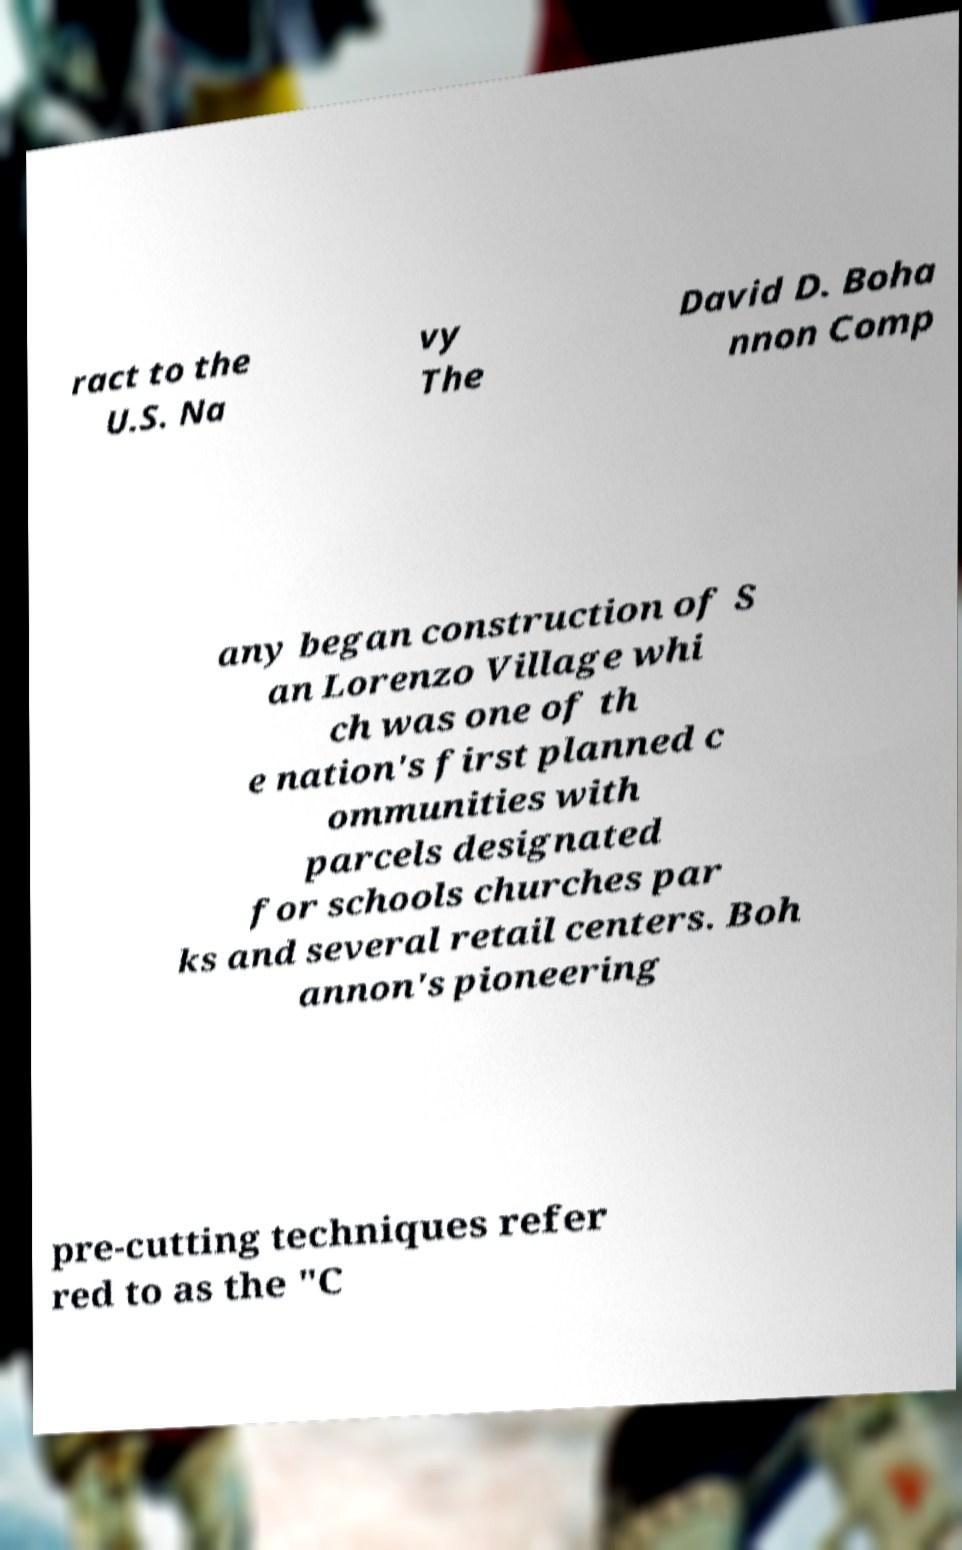Please identify and transcribe the text found in this image. ract to the U.S. Na vy The David D. Boha nnon Comp any began construction of S an Lorenzo Village whi ch was one of th e nation's first planned c ommunities with parcels designated for schools churches par ks and several retail centers. Boh annon's pioneering pre-cutting techniques refer red to as the "C 